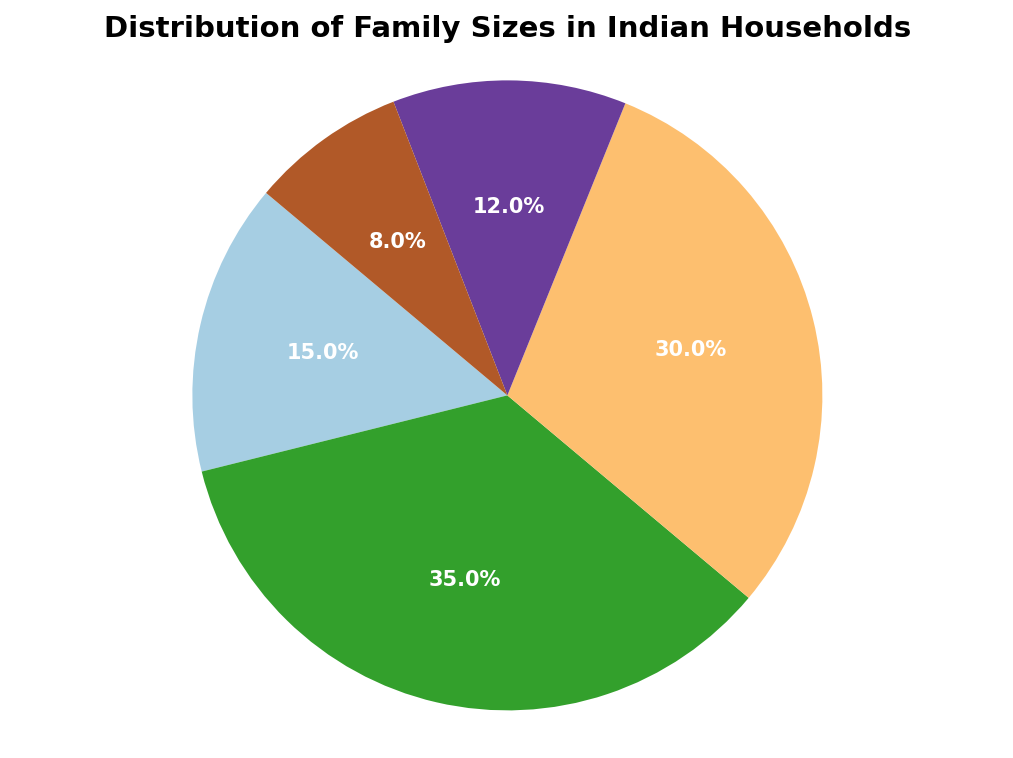What percentage of households have 3-4 members? Look at the section of the pie chart labeled "3-4 members" and read the corresponding percentage.
Answer: 35% Which family size occupies the least portion of the pie chart? Identify the smallest section of the pie chart, which has the label with the smallest corresponding percentage.
Answer: 9 or more members What is the total percentage of households with 5 or more members? Add the percentages of the "5-6 members", "7-8 members", and "9 or more members" sections: 30% + 12% + 8%.
Answer: 50% Compare the percentage of households with 1-2 members to those with 9 or more members. Which group is larger, and by how much? Look at the percentages for "1-2 members" and "9 or more members". Calculate the difference: 15% - 8%.
Answer: 1-2 members, by 7% What is the most common family size according to the pie chart? Identify the section of the pie chart with the largest percentage and read the corresponding label.
Answer: 3-4 members What fraction of the households have 3-6 members combined? Add the percentages of the "3-4 members" and "5-6 members" sections: 35% + 30%.
Answer: 65% What is the average percentage of households for family sizes ranging from 5 to 9 or more members? Calculate the average of the percentages for "5-6 members", "7-8 members" and "9 or more members": (30% + 12% + 8%) / 3.
Answer: 16.67% How much larger is the portion of households with 3-4 members compared to those with 7-8 members? Find the difference between the percentages for "3-4 members" and "7-8 members": 35% - 12%.
Answer: 23% If 1000 households were surveyed, how many households have 1-2 members? Calculate the number of households by multiplying 1000 by the percentage of "1-2 members": 1000 * 0.15.
Answer: 150 households 